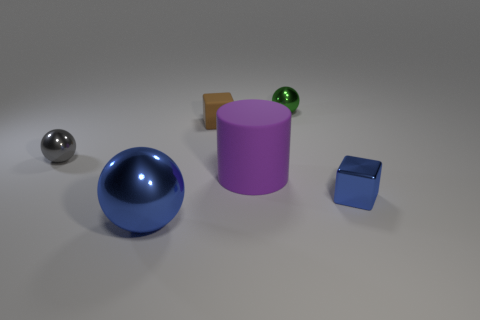Add 3 tiny shiny cylinders. How many objects exist? 9 Subtract all blocks. How many objects are left? 4 Add 5 big blue cubes. How many big blue cubes exist? 5 Subtract 1 blue cubes. How many objects are left? 5 Subtract all small gray spheres. Subtract all small shiny cubes. How many objects are left? 4 Add 3 purple objects. How many purple objects are left? 4 